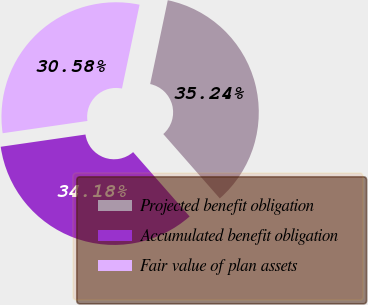Convert chart to OTSL. <chart><loc_0><loc_0><loc_500><loc_500><pie_chart><fcel>Projected benefit obligation<fcel>Accumulated benefit obligation<fcel>Fair value of plan assets<nl><fcel>35.24%<fcel>34.18%<fcel>30.58%<nl></chart> 